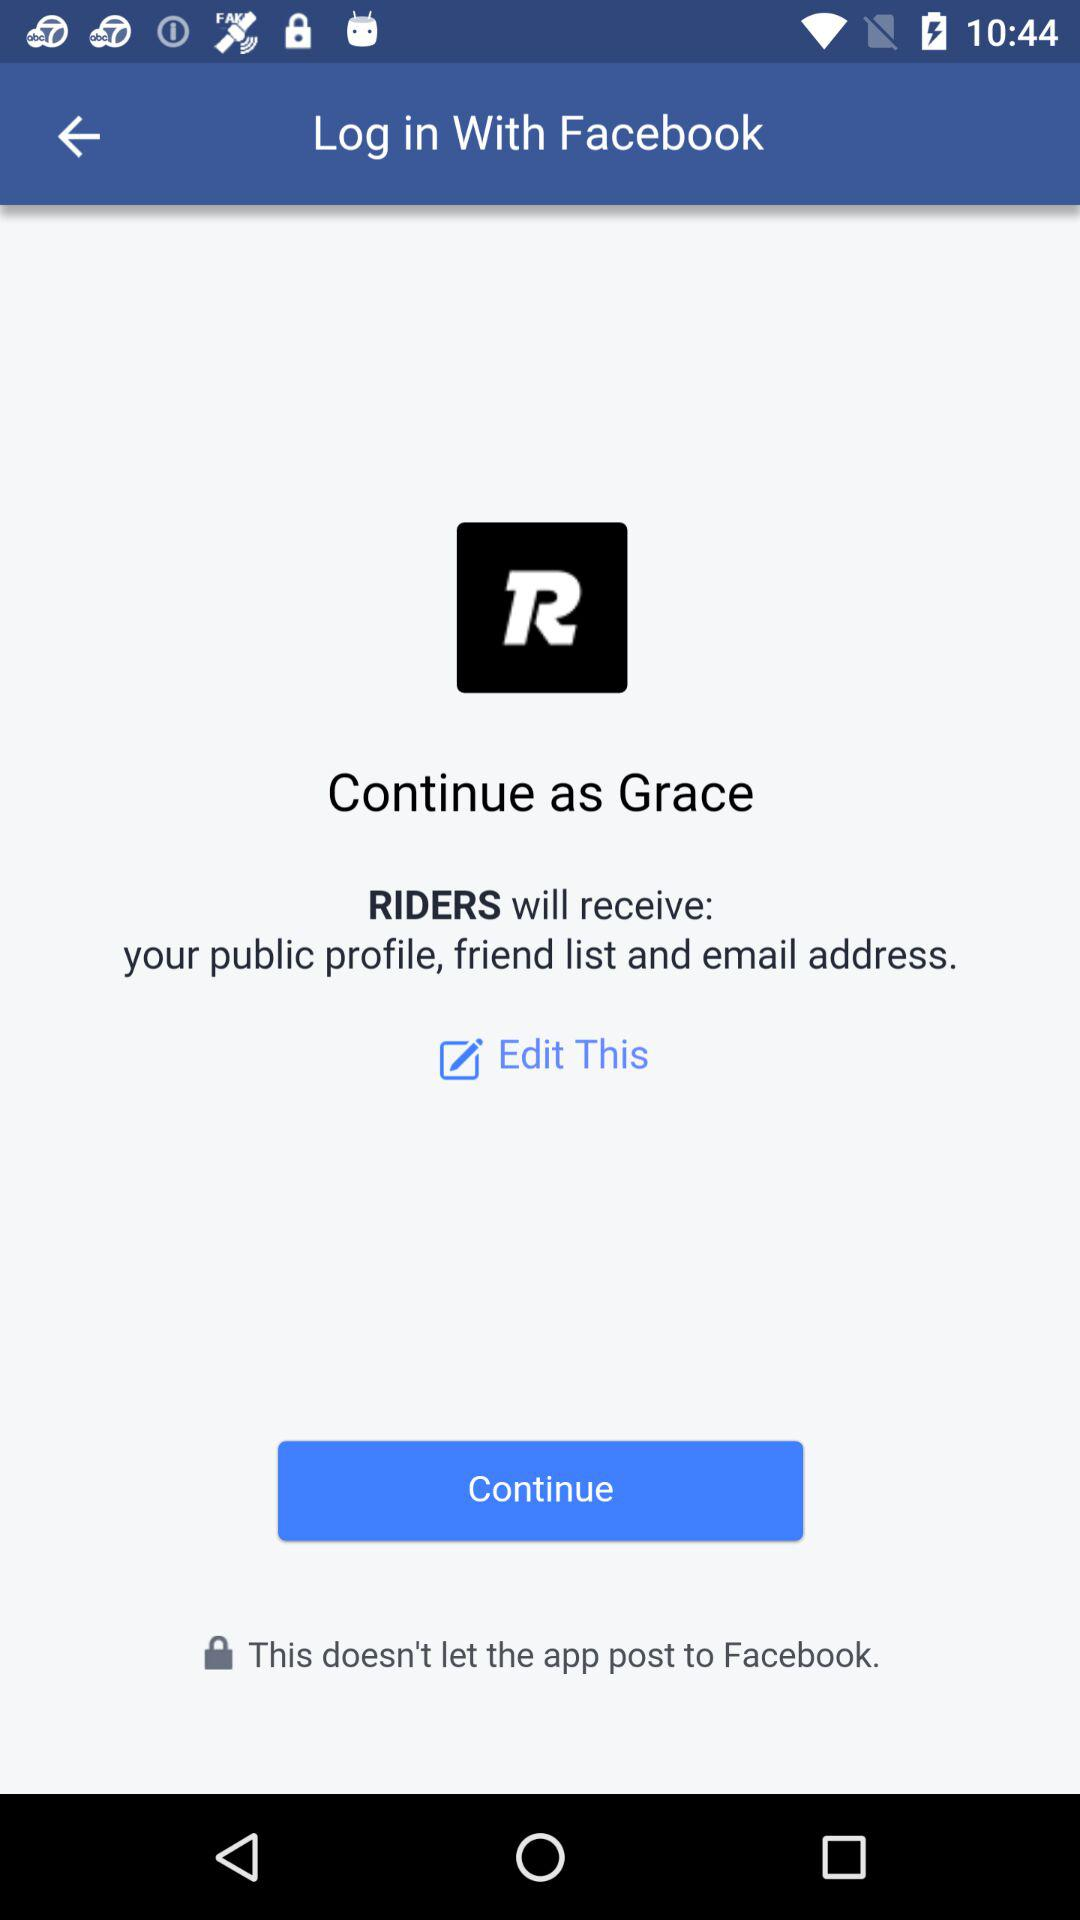What application can be used to log in to the profile? You can login with Facebook. 